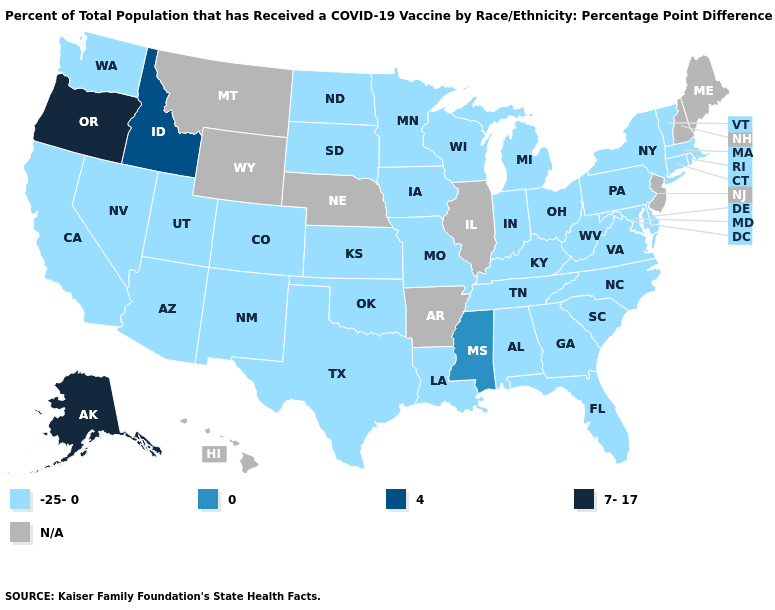How many symbols are there in the legend?
Short answer required. 5. What is the value of Arizona?
Give a very brief answer. -25-0. What is the highest value in the USA?
Be succinct. 7-17. What is the highest value in the South ?
Give a very brief answer. 0. What is the highest value in the USA?
Short answer required. 7-17. What is the lowest value in states that border Nebraska?
Concise answer only. -25-0. Does the map have missing data?
Write a very short answer. Yes. Among the states that border Oregon , which have the lowest value?
Be succinct. California, Nevada, Washington. What is the highest value in states that border Arkansas?
Quick response, please. 0. What is the value of Hawaii?
Give a very brief answer. N/A. What is the value of New Hampshire?
Keep it brief. N/A. Name the states that have a value in the range -25-0?
Concise answer only. Alabama, Arizona, California, Colorado, Connecticut, Delaware, Florida, Georgia, Indiana, Iowa, Kansas, Kentucky, Louisiana, Maryland, Massachusetts, Michigan, Minnesota, Missouri, Nevada, New Mexico, New York, North Carolina, North Dakota, Ohio, Oklahoma, Pennsylvania, Rhode Island, South Carolina, South Dakota, Tennessee, Texas, Utah, Vermont, Virginia, Washington, West Virginia, Wisconsin. What is the value of Texas?
Write a very short answer. -25-0. What is the lowest value in the South?
Keep it brief. -25-0. 